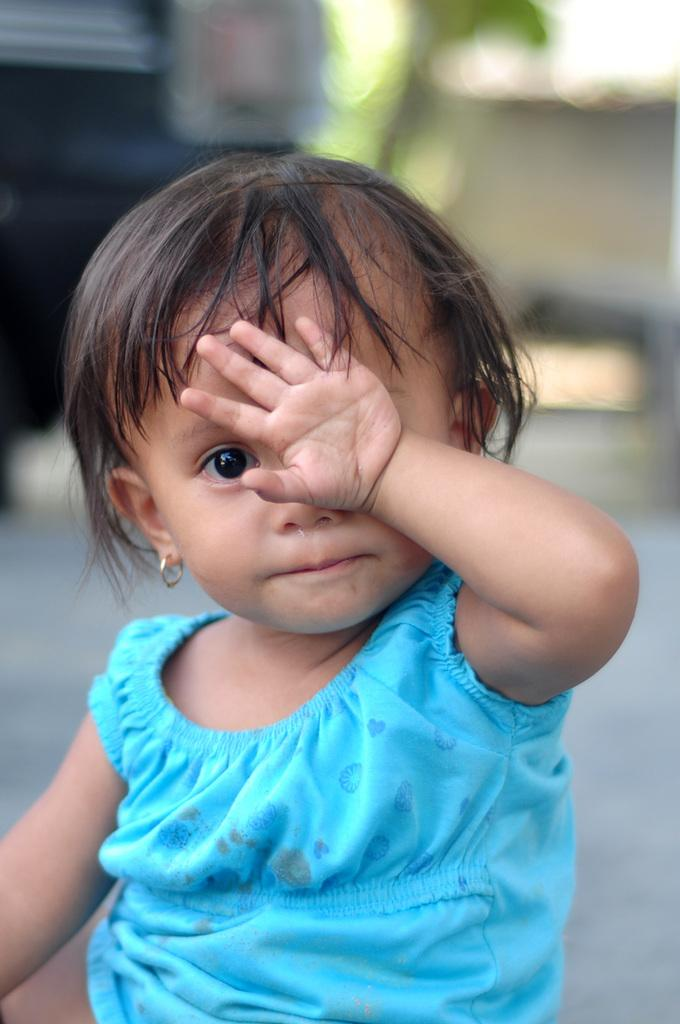Who is the main subject in the image? There is a girl in the image. Where is the girl located in the image? The girl is in the center of the image. What is the girl wearing in the image? The girl is wearing a blue dress. What type of invention can be seen in the girl's hand in the image? There is no invention visible in the girl's hand in the image. What type of tent is set up behind the girl in the image? There is no tent present in the image. 